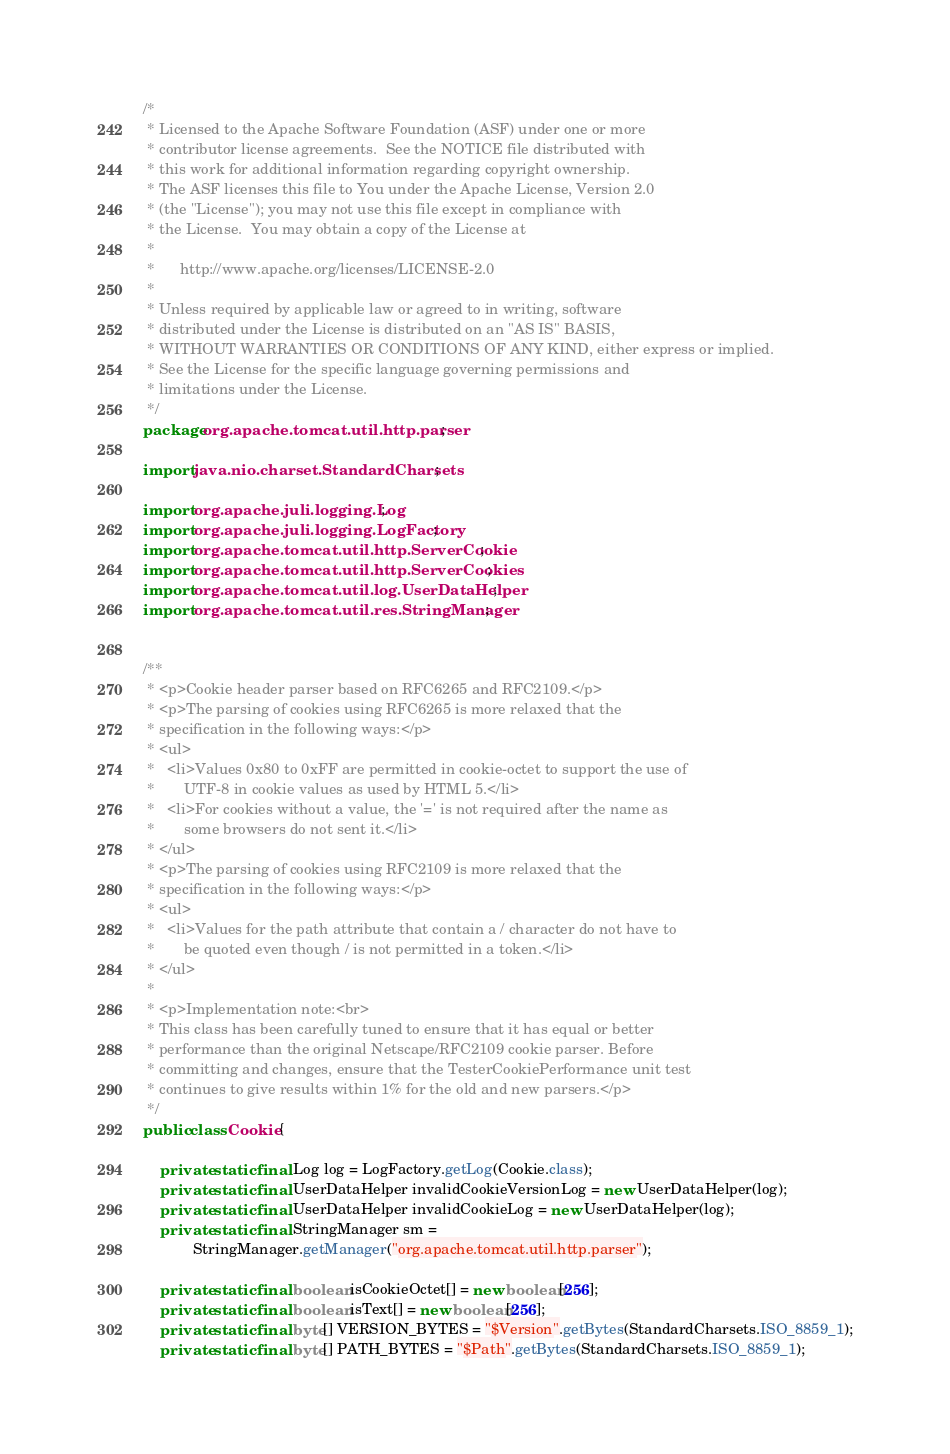<code> <loc_0><loc_0><loc_500><loc_500><_Java_>/*
 * Licensed to the Apache Software Foundation (ASF) under one or more
 * contributor license agreements.  See the NOTICE file distributed with
 * this work for additional information regarding copyright ownership.
 * The ASF licenses this file to You under the Apache License, Version 2.0
 * (the "License"); you may not use this file except in compliance with
 * the License.  You may obtain a copy of the License at
 *
 *      http://www.apache.org/licenses/LICENSE-2.0
 *
 * Unless required by applicable law or agreed to in writing, software
 * distributed under the License is distributed on an "AS IS" BASIS,
 * WITHOUT WARRANTIES OR CONDITIONS OF ANY KIND, either express or implied.
 * See the License for the specific language governing permissions and
 * limitations under the License.
 */
package org.apache.tomcat.util.http.parser;

import java.nio.charset.StandardCharsets;

import org.apache.juli.logging.Log;
import org.apache.juli.logging.LogFactory;
import org.apache.tomcat.util.http.ServerCookie;
import org.apache.tomcat.util.http.ServerCookies;
import org.apache.tomcat.util.log.UserDataHelper;
import org.apache.tomcat.util.res.StringManager;


/**
 * <p>Cookie header parser based on RFC6265 and RFC2109.</p>
 * <p>The parsing of cookies using RFC6265 is more relaxed that the
 * specification in the following ways:</p>
 * <ul>
 *   <li>Values 0x80 to 0xFF are permitted in cookie-octet to support the use of
 *       UTF-8 in cookie values as used by HTML 5.</li>
 *   <li>For cookies without a value, the '=' is not required after the name as
 *       some browsers do not sent it.</li>
 * </ul>
 * <p>The parsing of cookies using RFC2109 is more relaxed that the
 * specification in the following ways:</p>
 * <ul>
 *   <li>Values for the path attribute that contain a / character do not have to
 *       be quoted even though / is not permitted in a token.</li>
 * </ul>
 *
 * <p>Implementation note:<br>
 * This class has been carefully tuned to ensure that it has equal or better
 * performance than the original Netscape/RFC2109 cookie parser. Before
 * committing and changes, ensure that the TesterCookiePerformance unit test
 * continues to give results within 1% for the old and new parsers.</p>
 */
public class Cookie {

    private static final Log log = LogFactory.getLog(Cookie.class);
    private static final UserDataHelper invalidCookieVersionLog = new UserDataHelper(log);
    private static final UserDataHelper invalidCookieLog = new UserDataHelper(log);
    private static final StringManager sm =
            StringManager.getManager("org.apache.tomcat.util.http.parser");

    private static final boolean isCookieOctet[] = new boolean[256];
    private static final boolean isText[] = new boolean[256];
    private static final byte[] VERSION_BYTES = "$Version".getBytes(StandardCharsets.ISO_8859_1);
    private static final byte[] PATH_BYTES = "$Path".getBytes(StandardCharsets.ISO_8859_1);</code> 